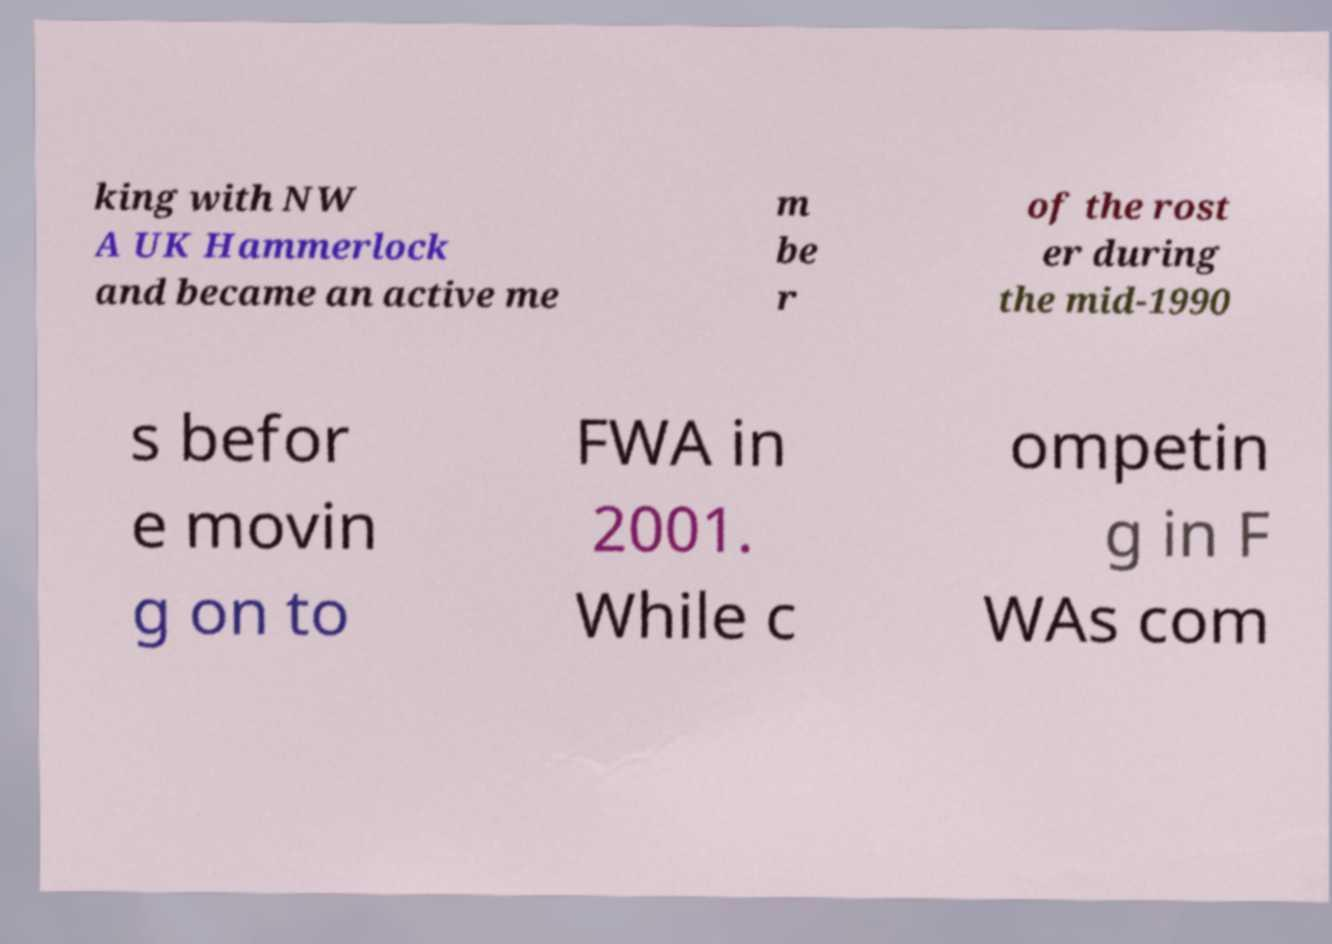Could you extract and type out the text from this image? king with NW A UK Hammerlock and became an active me m be r of the rost er during the mid-1990 s befor e movin g on to FWA in 2001. While c ompetin g in F WAs com 